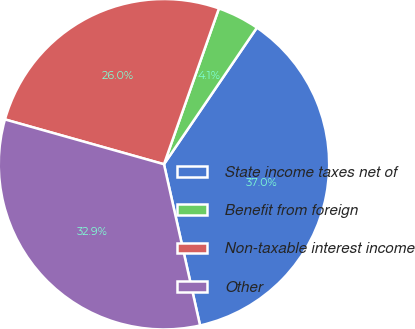Convert chart to OTSL. <chart><loc_0><loc_0><loc_500><loc_500><pie_chart><fcel>State income taxes net of<fcel>Benefit from foreign<fcel>Non-taxable interest income<fcel>Other<nl><fcel>36.99%<fcel>4.11%<fcel>26.03%<fcel>32.88%<nl></chart> 